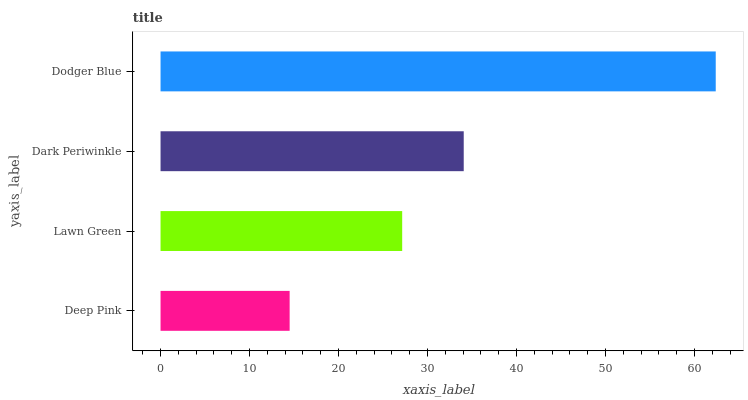Is Deep Pink the minimum?
Answer yes or no. Yes. Is Dodger Blue the maximum?
Answer yes or no. Yes. Is Lawn Green the minimum?
Answer yes or no. No. Is Lawn Green the maximum?
Answer yes or no. No. Is Lawn Green greater than Deep Pink?
Answer yes or no. Yes. Is Deep Pink less than Lawn Green?
Answer yes or no. Yes. Is Deep Pink greater than Lawn Green?
Answer yes or no. No. Is Lawn Green less than Deep Pink?
Answer yes or no. No. Is Dark Periwinkle the high median?
Answer yes or no. Yes. Is Lawn Green the low median?
Answer yes or no. Yes. Is Lawn Green the high median?
Answer yes or no. No. Is Deep Pink the low median?
Answer yes or no. No. 